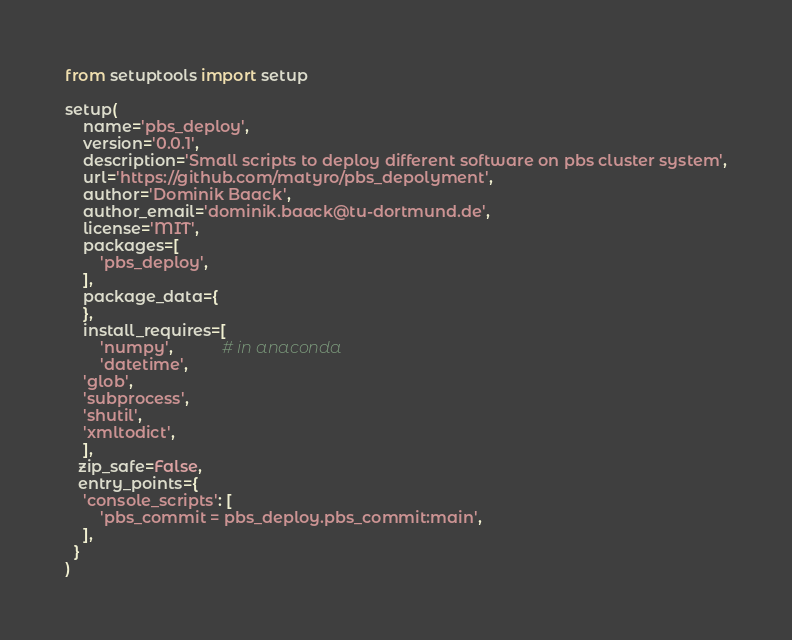Convert code to text. <code><loc_0><loc_0><loc_500><loc_500><_Python_>from setuptools import setup

setup(
    name='pbs_deploy',
    version='0.0.1',
    description='Small scripts to deploy different software on pbs cluster system',
    url='https://github.com/matyro/pbs_depolyment',
    author='Dominik Baack',
    author_email='dominik.baack@tu-dortmund.de',
    license='MIT',
    packages=[
        'pbs_deploy',
    ],
    package_data={
    },
    install_requires=[
        'numpy',           # in anaconda
        'datetime',
	'glob',
	'subprocess',
	'shutil',
	'xmltodict',
    ],
   zip_safe=False,
   entry_points={
    'console_scripts': [
        'pbs_commit = pbs_deploy.pbs_commit:main',
    ],
  }
)
</code> 